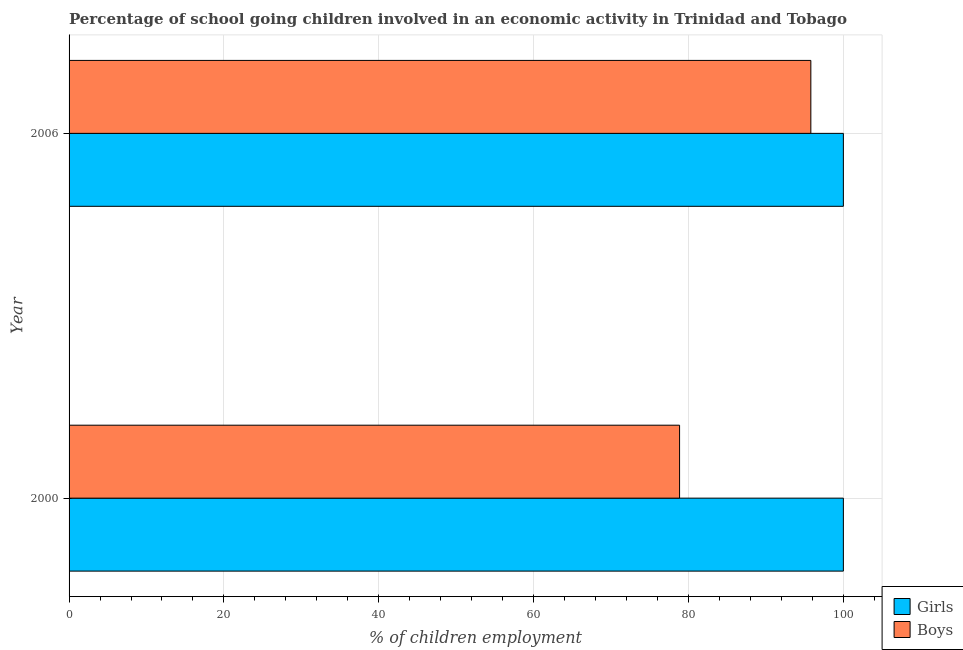How many different coloured bars are there?
Make the answer very short. 2. How many bars are there on the 1st tick from the bottom?
Provide a short and direct response. 2. In how many cases, is the number of bars for a given year not equal to the number of legend labels?
Your response must be concise. 0. What is the percentage of school going girls in 2006?
Provide a succinct answer. 100. Across all years, what is the maximum percentage of school going girls?
Provide a short and direct response. 100. Across all years, what is the minimum percentage of school going girls?
Keep it short and to the point. 100. In which year was the percentage of school going girls minimum?
Provide a succinct answer. 2000. What is the total percentage of school going boys in the graph?
Offer a very short reply. 174.65. What is the difference between the percentage of school going boys in 2000 and that in 2006?
Offer a terse response. -16.95. What is the difference between the percentage of school going boys in 2000 and the percentage of school going girls in 2006?
Provide a succinct answer. -21.15. What is the average percentage of school going boys per year?
Your response must be concise. 87.32. In the year 2000, what is the difference between the percentage of school going girls and percentage of school going boys?
Your response must be concise. 21.15. In how many years, is the percentage of school going boys greater than 12 %?
Provide a succinct answer. 2. What is the ratio of the percentage of school going girls in 2000 to that in 2006?
Offer a terse response. 1. Is the percentage of school going boys in 2000 less than that in 2006?
Offer a terse response. Yes. Is the difference between the percentage of school going girls in 2000 and 2006 greater than the difference between the percentage of school going boys in 2000 and 2006?
Offer a terse response. Yes. In how many years, is the percentage of school going boys greater than the average percentage of school going boys taken over all years?
Offer a very short reply. 1. What does the 2nd bar from the top in 2000 represents?
Offer a terse response. Girls. What does the 1st bar from the bottom in 2000 represents?
Offer a terse response. Girls. Are the values on the major ticks of X-axis written in scientific E-notation?
Keep it short and to the point. No. Where does the legend appear in the graph?
Offer a terse response. Bottom right. What is the title of the graph?
Keep it short and to the point. Percentage of school going children involved in an economic activity in Trinidad and Tobago. Does "Investment in Transport" appear as one of the legend labels in the graph?
Your answer should be very brief. No. What is the label or title of the X-axis?
Offer a very short reply. % of children employment. What is the label or title of the Y-axis?
Offer a very short reply. Year. What is the % of children employment of Girls in 2000?
Provide a succinct answer. 100. What is the % of children employment in Boys in 2000?
Your answer should be very brief. 78.85. What is the % of children employment of Girls in 2006?
Make the answer very short. 100. What is the % of children employment in Boys in 2006?
Offer a terse response. 95.8. Across all years, what is the maximum % of children employment of Boys?
Provide a short and direct response. 95.8. Across all years, what is the minimum % of children employment in Girls?
Keep it short and to the point. 100. Across all years, what is the minimum % of children employment in Boys?
Keep it short and to the point. 78.85. What is the total % of children employment in Girls in the graph?
Make the answer very short. 200. What is the total % of children employment in Boys in the graph?
Your response must be concise. 174.65. What is the difference between the % of children employment in Girls in 2000 and that in 2006?
Your answer should be compact. 0. What is the difference between the % of children employment of Boys in 2000 and that in 2006?
Your answer should be compact. -16.95. What is the difference between the % of children employment of Girls in 2000 and the % of children employment of Boys in 2006?
Make the answer very short. 4.2. What is the average % of children employment in Girls per year?
Offer a terse response. 100. What is the average % of children employment in Boys per year?
Your answer should be very brief. 87.32. In the year 2000, what is the difference between the % of children employment of Girls and % of children employment of Boys?
Ensure brevity in your answer.  21.15. In the year 2006, what is the difference between the % of children employment of Girls and % of children employment of Boys?
Offer a terse response. 4.2. What is the ratio of the % of children employment of Girls in 2000 to that in 2006?
Give a very brief answer. 1. What is the ratio of the % of children employment in Boys in 2000 to that in 2006?
Your answer should be compact. 0.82. What is the difference between the highest and the second highest % of children employment of Boys?
Your answer should be compact. 16.95. What is the difference between the highest and the lowest % of children employment in Girls?
Make the answer very short. 0. What is the difference between the highest and the lowest % of children employment in Boys?
Give a very brief answer. 16.95. 